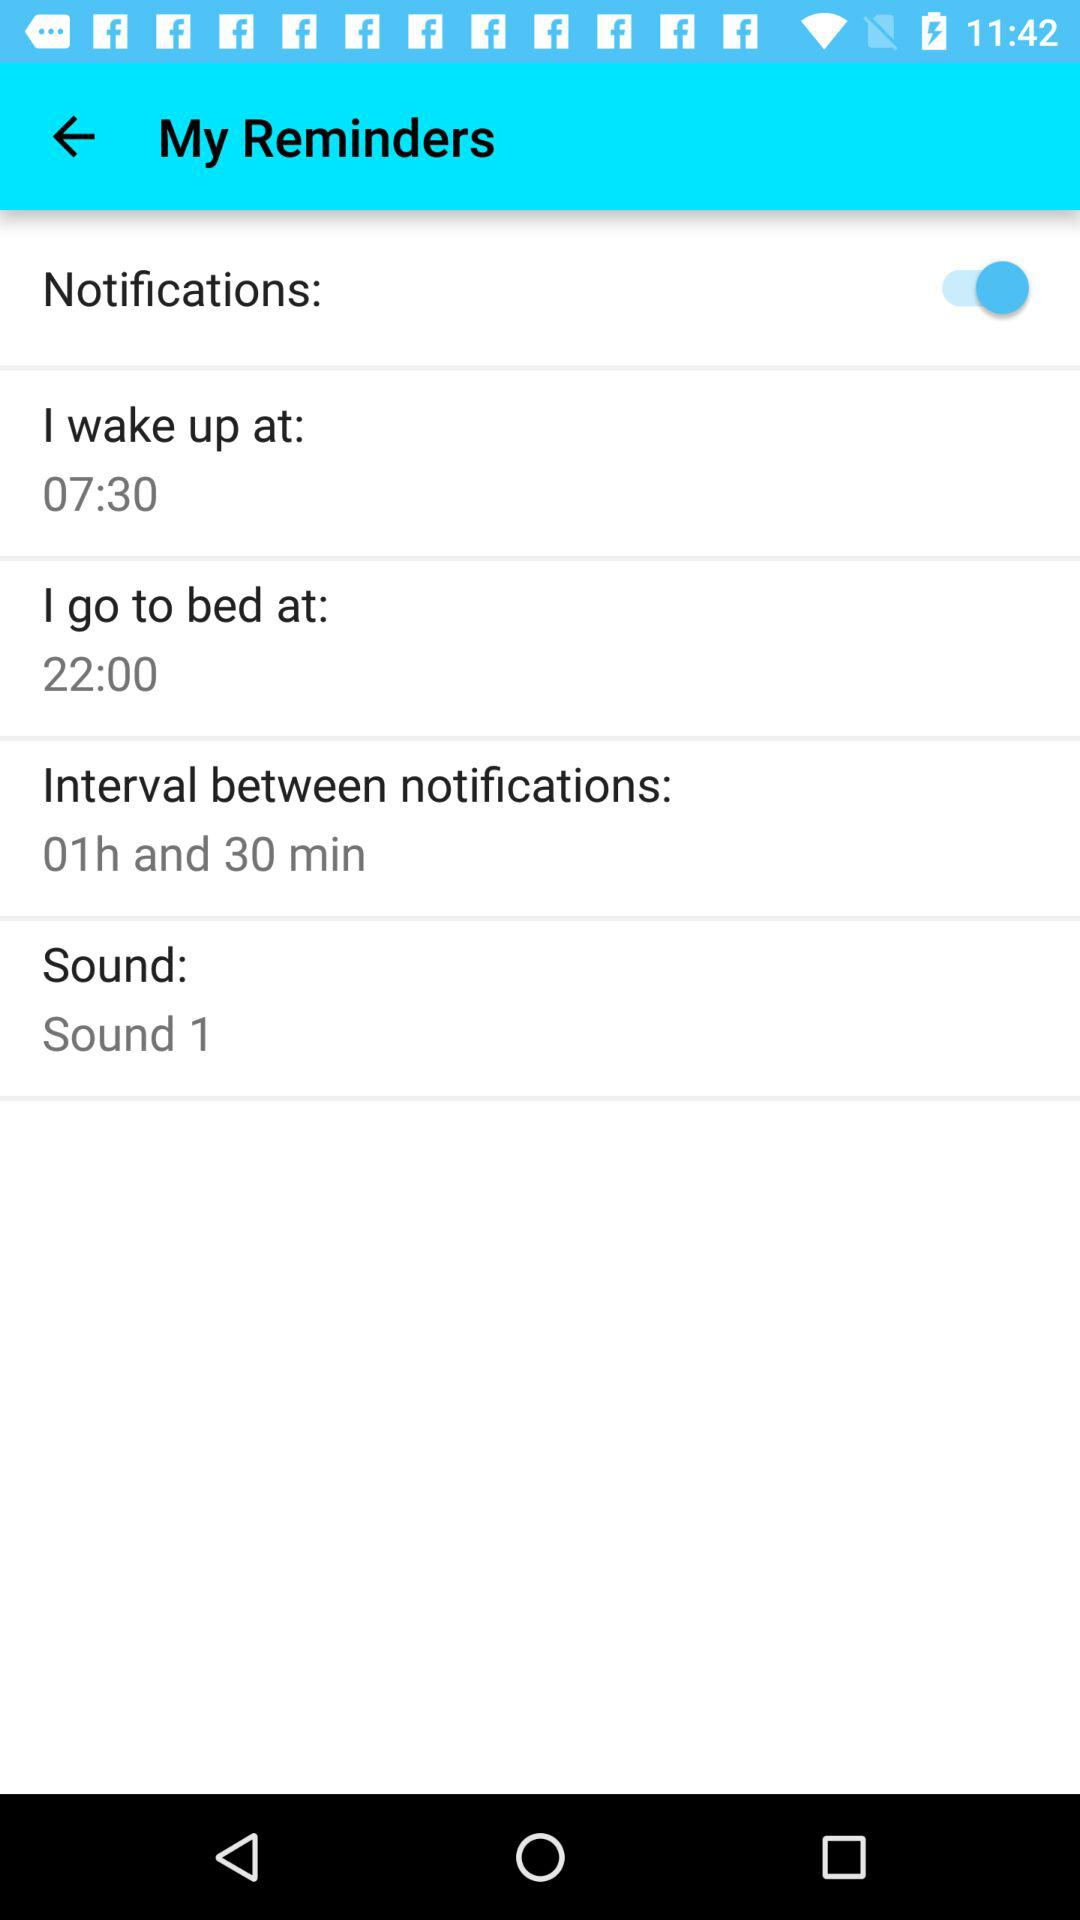How long is the interval between notifications? The interval between notifications is 1 hour 30 minutes long. 